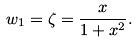<formula> <loc_0><loc_0><loc_500><loc_500>w _ { 1 } = \zeta = \frac { x } { 1 + x ^ { 2 } } .</formula> 